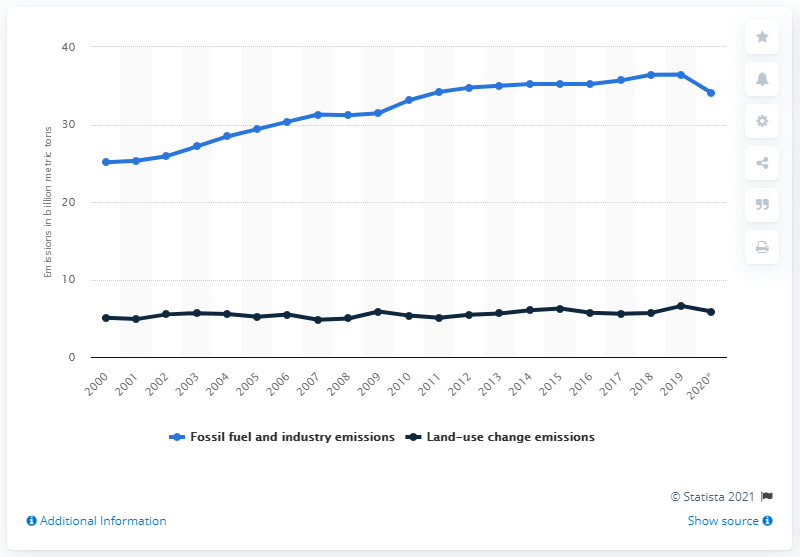Outline some significant characteristics in this image. By 2019, global emissions had reached a record high of 36.44 gigatons of carbon dioxide equivalent. Emissions dropped in the year 2009. 